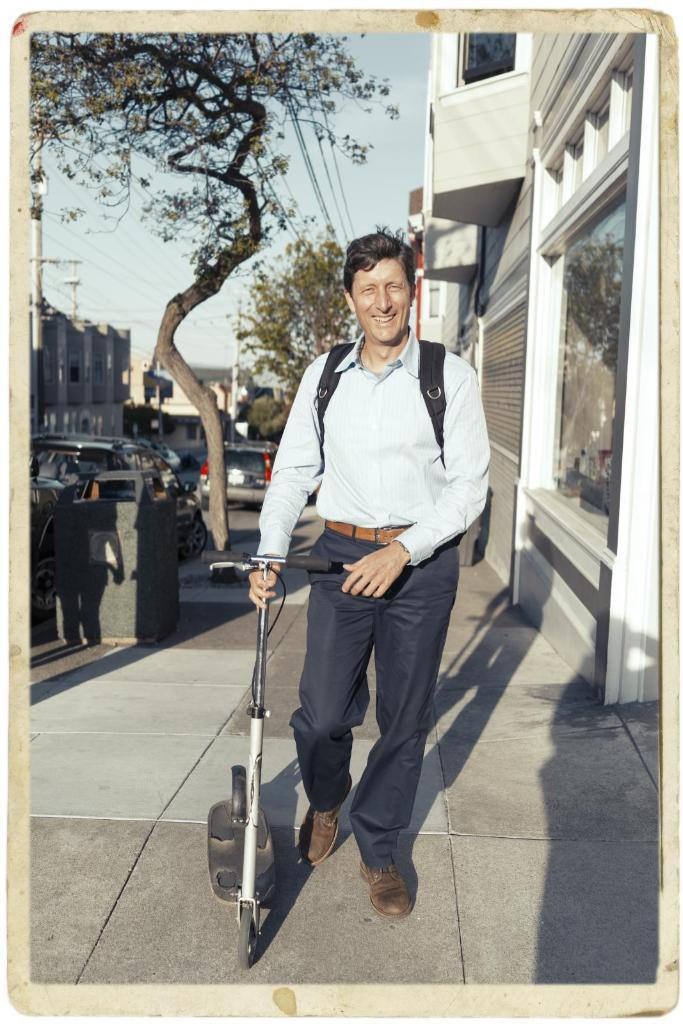What is the main subject of the image? The main subject of the image is a man. What is the man holding in the image? The man is holding a scooter with his hand. What is the man's facial expression in the image? The man is smiling in the image. What can be seen on the road in the image? There are cars on the road in the image. What type of vegetation is present in the image? There are trees in the image. What type of structures are present in the image? There are poles and buildings in the image. What is the man standing near in the image? There is a bin in the image. What is visible in the background of the image? The sky is visible in the background of the image. How many rings is the man wearing on his fingers in the image? There is no mention of rings in the image, so it cannot be determined how many rings the man is wearing. 